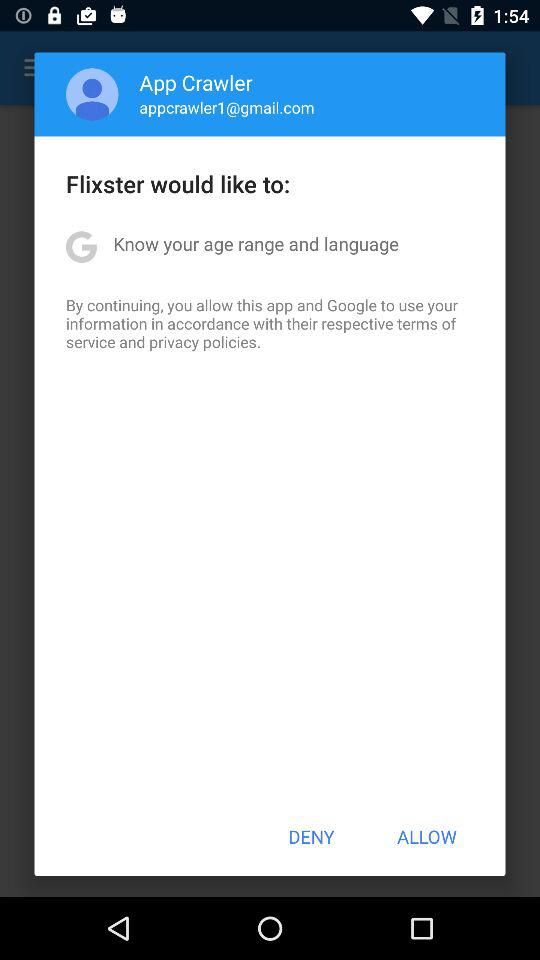What is the user name? The user name is "App Crawler". 